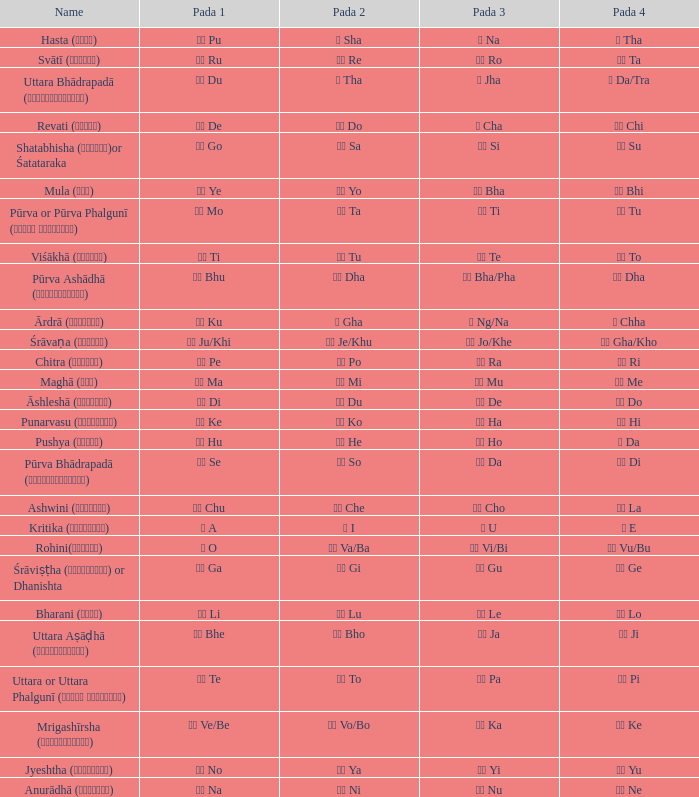Could you parse the entire table as a dict? {'header': ['Name', 'Pada 1', 'Pada 2', 'Pada 3', 'Pada 4'], 'rows': [['Hasta (हस्त)', 'पू Pu', 'ष Sha', 'ण Na', 'ठ Tha'], ['Svātī (स्वाति)', 'रू Ru', 'रे Re', 'रो Ro', 'ता Ta'], ['Uttara Bhādrapadā (उत्तरभाद्रपदा)', 'दू Du', 'थ Tha', 'झ Jha', 'ञ Da/Tra'], ['Revati (रेवती)', 'दे De', 'दो Do', 'च Cha', 'ची Chi'], ['Shatabhisha (शतभिषा)or Śatataraka', 'गो Go', 'सा Sa', 'सी Si', 'सू Su'], ['Mula (मूल)', 'ये Ye', 'यो Yo', 'भा Bha', 'भी Bhi'], ['Pūrva or Pūrva Phalgunī (पूर्व फाल्गुनी)', 'नो Mo', 'टा Ta', 'टी Ti', 'टू Tu'], ['Viśākhā (विशाखा)', 'ती Ti', 'तू Tu', 'ते Te', 'तो To'], ['Pūrva Ashādhā (पूर्वाषाढ़ा)', 'भू Bhu', 'धा Dha', 'फा Bha/Pha', 'ढा Dha'], ['Ārdrā (आर्द्रा)', 'कु Ku', 'घ Gha', 'ङ Ng/Na', 'छ Chha'], ['Śrāvaṇa (श्र\u200cावण)', 'खी Ju/Khi', 'खू Je/Khu', 'खे Jo/Khe', 'खो Gha/Kho'], ['Chitra (चित्रा)', 'पे Pe', 'पो Po', 'रा Ra', 'री Ri'], ['Maghā (मघा)', 'मा Ma', 'मी Mi', 'मू Mu', 'मे Me'], ['Āshleshā (आश्लेषा)', 'डी Di', 'डू Du', 'डे De', 'डो Do'], ['Punarvasu (पुनर्वसु)', 'के Ke', 'को Ko', 'हा Ha', 'ही Hi'], ['Pushya (पुष्य)', 'हु Hu', 'हे He', 'हो Ho', 'ड Da'], ['Pūrva Bhādrapadā (पूर्वभाद्रपदा)', 'से Se', 'सो So', 'दा Da', 'दी Di'], ['Ashwini (अश्विनि)', 'चु Chu', 'चे Che', 'चो Cho', 'ला La'], ['Kritika (कृत्तिका)', 'अ A', 'ई I', 'उ U', 'ए E'], ['Rohini(रोहिणी)', 'ओ O', 'वा Va/Ba', 'वी Vi/Bi', 'वु Vu/Bu'], ['Śrāviṣṭha (श्रविष्ठा) or Dhanishta', 'गा Ga', 'गी Gi', 'गु Gu', 'गे Ge'], ['Bharani (भरणी)', 'ली Li', 'लू Lu', 'ले Le', 'लो Lo'], ['Uttara Aṣāḍhā (उत्तराषाढ़ा)', 'भे Bhe', 'भो Bho', 'जा Ja', 'जी Ji'], ['Uttara or Uttara Phalgunī (उत्तर फाल्गुनी)', 'टे Te', 'टो To', 'पा Pa', 'पी Pi'], ['Mrigashīrsha (म्रृगशीर्षा)', 'वे Ve/Be', 'वो Vo/Bo', 'का Ka', 'की Ke'], ['Jyeshtha (ज्येष्ठा)', 'नो No', 'या Ya', 'यी Yi', 'यू Yu'], ['Anurādhā (अनुराधा)', 'ना Na', 'नी Ni', 'नू Nu', 'ने Ne']]} What kind of Pada 4 has a Pada 1 of खी ju/khi? खो Gha/Kho. 